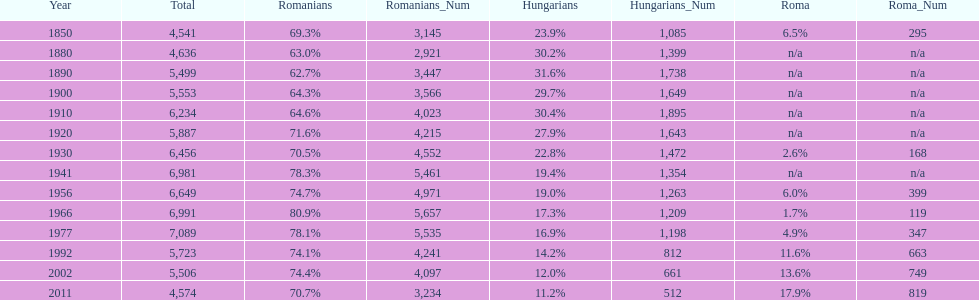What were the total number of times the romanians had a population percentage above 70%? 9. 